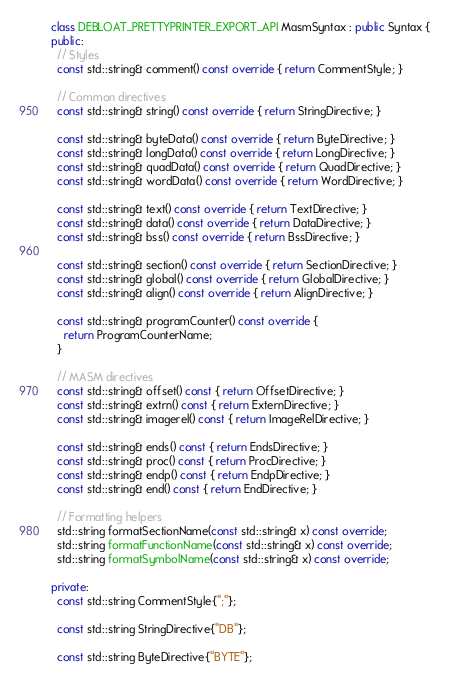Convert code to text. <code><loc_0><loc_0><loc_500><loc_500><_C++_>
class DEBLOAT_PRETTYPRINTER_EXPORT_API MasmSyntax : public Syntax {
public:
  // Styles
  const std::string& comment() const override { return CommentStyle; }

  // Common directives
  const std::string& string() const override { return StringDirective; }

  const std::string& byteData() const override { return ByteDirective; }
  const std::string& longData() const override { return LongDirective; }
  const std::string& quadData() const override { return QuadDirective; }
  const std::string& wordData() const override { return WordDirective; }

  const std::string& text() const override { return TextDirective; }
  const std::string& data() const override { return DataDirective; }
  const std::string& bss() const override { return BssDirective; }

  const std::string& section() const override { return SectionDirective; }
  const std::string& global() const override { return GlobalDirective; }
  const std::string& align() const override { return AlignDirective; }

  const std::string& programCounter() const override {
    return ProgramCounterName;
  }

  // MASM directives
  const std::string& offset() const { return OffsetDirective; }
  const std::string& extrn() const { return ExternDirective; }
  const std::string& imagerel() const { return ImageRelDirective; }

  const std::string& ends() const { return EndsDirective; }
  const std::string& proc() const { return ProcDirective; }
  const std::string& endp() const { return EndpDirective; }
  const std::string& end() const { return EndDirective; }

  // Formatting helpers
  std::string formatSectionName(const std::string& x) const override;
  std::string formatFunctionName(const std::string& x) const override;
  std::string formatSymbolName(const std::string& x) const override;

private:
  const std::string CommentStyle{";"};

  const std::string StringDirective{"DB"};

  const std::string ByteDirective{"BYTE"};</code> 